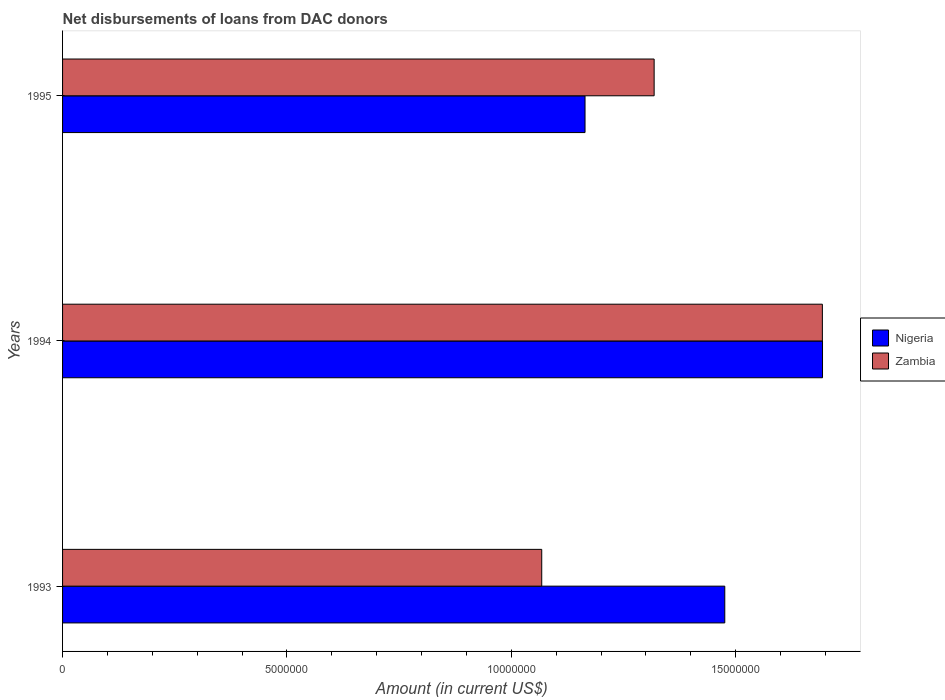How many different coloured bars are there?
Your answer should be very brief. 2. How many groups of bars are there?
Provide a succinct answer. 3. Are the number of bars per tick equal to the number of legend labels?
Make the answer very short. Yes. Are the number of bars on each tick of the Y-axis equal?
Your answer should be compact. Yes. What is the label of the 1st group of bars from the top?
Ensure brevity in your answer.  1995. What is the amount of loans disbursed in Zambia in 1993?
Ensure brevity in your answer.  1.07e+07. Across all years, what is the maximum amount of loans disbursed in Zambia?
Provide a short and direct response. 1.69e+07. Across all years, what is the minimum amount of loans disbursed in Nigeria?
Make the answer very short. 1.16e+07. In which year was the amount of loans disbursed in Nigeria minimum?
Your answer should be compact. 1995. What is the total amount of loans disbursed in Zambia in the graph?
Provide a short and direct response. 4.08e+07. What is the difference between the amount of loans disbursed in Nigeria in 1993 and that in 1995?
Offer a terse response. 3.11e+06. What is the difference between the amount of loans disbursed in Zambia in 1993 and the amount of loans disbursed in Nigeria in 1995?
Give a very brief answer. -9.65e+05. What is the average amount of loans disbursed in Zambia per year?
Give a very brief answer. 1.36e+07. In the year 1995, what is the difference between the amount of loans disbursed in Nigeria and amount of loans disbursed in Zambia?
Your answer should be compact. -1.54e+06. In how many years, is the amount of loans disbursed in Nigeria greater than 6000000 US$?
Ensure brevity in your answer.  3. What is the ratio of the amount of loans disbursed in Nigeria in 1993 to that in 1995?
Your answer should be very brief. 1.27. What is the difference between the highest and the second highest amount of loans disbursed in Nigeria?
Give a very brief answer. 2.18e+06. What is the difference between the highest and the lowest amount of loans disbursed in Nigeria?
Make the answer very short. 5.29e+06. Is the sum of the amount of loans disbursed in Nigeria in 1993 and 1995 greater than the maximum amount of loans disbursed in Zambia across all years?
Make the answer very short. Yes. What does the 2nd bar from the top in 1993 represents?
Your response must be concise. Nigeria. What does the 2nd bar from the bottom in 1995 represents?
Your answer should be very brief. Zambia. How many bars are there?
Make the answer very short. 6. Are all the bars in the graph horizontal?
Offer a very short reply. Yes. What is the difference between two consecutive major ticks on the X-axis?
Offer a very short reply. 5.00e+06. Are the values on the major ticks of X-axis written in scientific E-notation?
Provide a short and direct response. No. Where does the legend appear in the graph?
Ensure brevity in your answer.  Center right. How many legend labels are there?
Provide a succinct answer. 2. How are the legend labels stacked?
Offer a very short reply. Vertical. What is the title of the graph?
Keep it short and to the point. Net disbursements of loans from DAC donors. What is the label or title of the X-axis?
Offer a very short reply. Amount (in current US$). What is the Amount (in current US$) in Nigeria in 1993?
Offer a very short reply. 1.48e+07. What is the Amount (in current US$) in Zambia in 1993?
Provide a succinct answer. 1.07e+07. What is the Amount (in current US$) of Nigeria in 1994?
Keep it short and to the point. 1.69e+07. What is the Amount (in current US$) of Zambia in 1994?
Your answer should be compact. 1.69e+07. What is the Amount (in current US$) in Nigeria in 1995?
Your answer should be compact. 1.16e+07. What is the Amount (in current US$) in Zambia in 1995?
Keep it short and to the point. 1.32e+07. Across all years, what is the maximum Amount (in current US$) of Nigeria?
Your response must be concise. 1.69e+07. Across all years, what is the maximum Amount (in current US$) in Zambia?
Your answer should be very brief. 1.69e+07. Across all years, what is the minimum Amount (in current US$) of Nigeria?
Ensure brevity in your answer.  1.16e+07. Across all years, what is the minimum Amount (in current US$) of Zambia?
Your answer should be very brief. 1.07e+07. What is the total Amount (in current US$) in Nigeria in the graph?
Give a very brief answer. 4.33e+07. What is the total Amount (in current US$) of Zambia in the graph?
Keep it short and to the point. 4.08e+07. What is the difference between the Amount (in current US$) in Nigeria in 1993 and that in 1994?
Keep it short and to the point. -2.18e+06. What is the difference between the Amount (in current US$) of Zambia in 1993 and that in 1994?
Ensure brevity in your answer.  -6.25e+06. What is the difference between the Amount (in current US$) of Nigeria in 1993 and that in 1995?
Offer a terse response. 3.11e+06. What is the difference between the Amount (in current US$) in Zambia in 1993 and that in 1995?
Provide a short and direct response. -2.50e+06. What is the difference between the Amount (in current US$) of Nigeria in 1994 and that in 1995?
Your answer should be very brief. 5.29e+06. What is the difference between the Amount (in current US$) of Zambia in 1994 and that in 1995?
Offer a terse response. 3.75e+06. What is the difference between the Amount (in current US$) in Nigeria in 1993 and the Amount (in current US$) in Zambia in 1994?
Give a very brief answer. -2.18e+06. What is the difference between the Amount (in current US$) in Nigeria in 1993 and the Amount (in current US$) in Zambia in 1995?
Offer a very short reply. 1.57e+06. What is the difference between the Amount (in current US$) in Nigeria in 1994 and the Amount (in current US$) in Zambia in 1995?
Provide a short and direct response. 3.75e+06. What is the average Amount (in current US$) of Nigeria per year?
Ensure brevity in your answer.  1.44e+07. What is the average Amount (in current US$) in Zambia per year?
Make the answer very short. 1.36e+07. In the year 1993, what is the difference between the Amount (in current US$) of Nigeria and Amount (in current US$) of Zambia?
Your answer should be compact. 4.08e+06. In the year 1994, what is the difference between the Amount (in current US$) in Nigeria and Amount (in current US$) in Zambia?
Give a very brief answer. 3000. In the year 1995, what is the difference between the Amount (in current US$) of Nigeria and Amount (in current US$) of Zambia?
Ensure brevity in your answer.  -1.54e+06. What is the ratio of the Amount (in current US$) in Nigeria in 1993 to that in 1994?
Your response must be concise. 0.87. What is the ratio of the Amount (in current US$) in Zambia in 1993 to that in 1994?
Your answer should be compact. 0.63. What is the ratio of the Amount (in current US$) of Nigeria in 1993 to that in 1995?
Provide a succinct answer. 1.27. What is the ratio of the Amount (in current US$) in Zambia in 1993 to that in 1995?
Offer a very short reply. 0.81. What is the ratio of the Amount (in current US$) of Nigeria in 1994 to that in 1995?
Keep it short and to the point. 1.45. What is the ratio of the Amount (in current US$) in Zambia in 1994 to that in 1995?
Ensure brevity in your answer.  1.28. What is the difference between the highest and the second highest Amount (in current US$) of Nigeria?
Provide a succinct answer. 2.18e+06. What is the difference between the highest and the second highest Amount (in current US$) in Zambia?
Your answer should be compact. 3.75e+06. What is the difference between the highest and the lowest Amount (in current US$) in Nigeria?
Offer a very short reply. 5.29e+06. What is the difference between the highest and the lowest Amount (in current US$) in Zambia?
Offer a very short reply. 6.25e+06. 